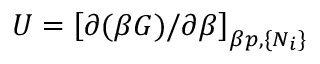<formula> <loc_0><loc_0><loc_500><loc_500>U = \left [ \partial ( \beta G ) / \partial \beta \right ] _ { \beta p , \{ N _ { i } \} }</formula> 